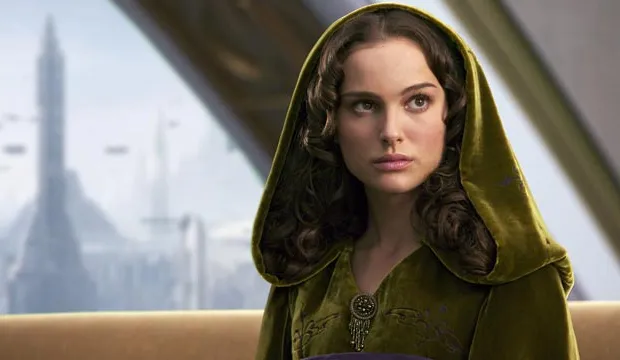What might the character's expression suggest about her thoughts or situation? The character's expression is one of seriousness and contemplation, which might suggest she is engaged in deep thought about pressing matters within her society or personal life. Her slight gaze towards the side could indicate introspection or concern, perhaps about decisions she needs to make or challenges she is facing. The expression can be interpreted as reflective of the responsibilities or burdens carried by someone of her apparent status, possibly hinting at a narrative where leadership and moral dilemmas play significant roles. 